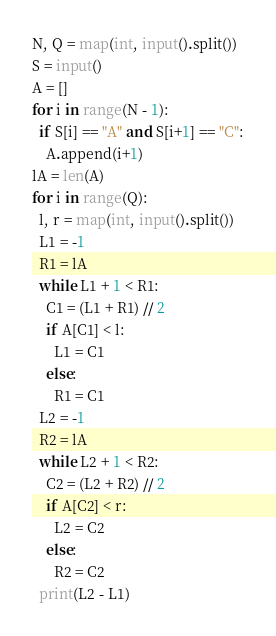Convert code to text. <code><loc_0><loc_0><loc_500><loc_500><_Python_>N, Q = map(int, input().split())
S = input()
A = []
for i in range(N - 1):
  if S[i] == "A" and S[i+1] == "C":
    A.append(i+1)
lA = len(A)
for i in range(Q):
  l, r = map(int, input().split())
  L1 = -1
  R1 = lA
  while L1 + 1 < R1:
    C1 = (L1 + R1) // 2
    if A[C1] < l:
      L1 = C1
    else:
      R1 = C1
  L2 = -1
  R2 = lA
  while L2 + 1 < R2:
    C2 = (L2 + R2) // 2
    if A[C2] < r:
      L2 = C2
    else:
      R2 = C2
  print(L2 - L1)</code> 